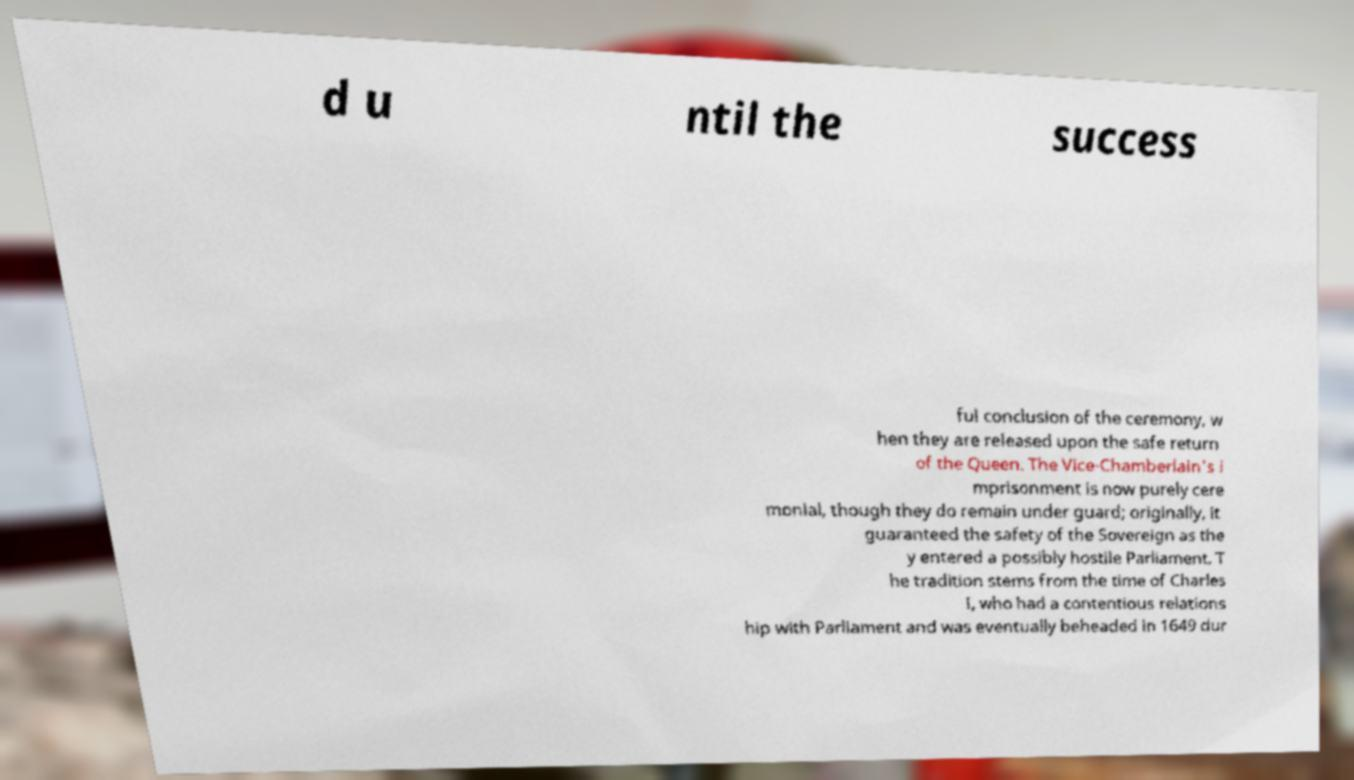Please read and relay the text visible in this image. What does it say? d u ntil the success ful conclusion of the ceremony, w hen they are released upon the safe return of the Queen. The Vice-Chamberlain's i mprisonment is now purely cere monial, though they do remain under guard; originally, it guaranteed the safety of the Sovereign as the y entered a possibly hostile Parliament. T he tradition stems from the time of Charles I, who had a contentious relations hip with Parliament and was eventually beheaded in 1649 dur 